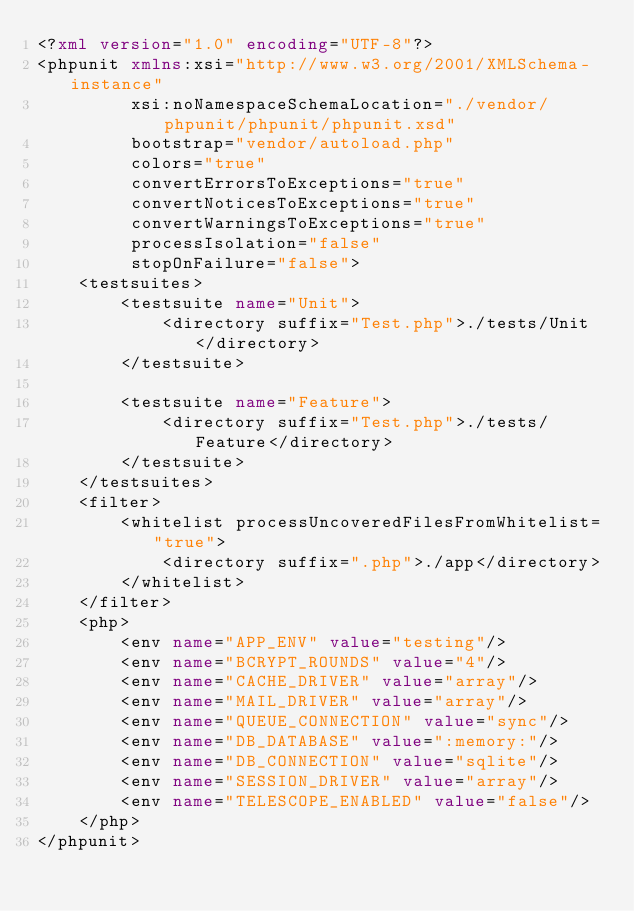Convert code to text. <code><loc_0><loc_0><loc_500><loc_500><_XML_><?xml version="1.0" encoding="UTF-8"?>
<phpunit xmlns:xsi="http://www.w3.org/2001/XMLSchema-instance"
         xsi:noNamespaceSchemaLocation="./vendor/phpunit/phpunit/phpunit.xsd"
         bootstrap="vendor/autoload.php"
         colors="true"
         convertErrorsToExceptions="true"
         convertNoticesToExceptions="true"
         convertWarningsToExceptions="true"
         processIsolation="false"
         stopOnFailure="false">
    <testsuites>
        <testsuite name="Unit">
            <directory suffix="Test.php">./tests/Unit</directory>
        </testsuite>

        <testsuite name="Feature">
            <directory suffix="Test.php">./tests/Feature</directory>
        </testsuite>
    </testsuites>
    <filter>
        <whitelist processUncoveredFilesFromWhitelist="true">
            <directory suffix=".php">./app</directory>
        </whitelist>
    </filter>
    <php>
        <env name="APP_ENV" value="testing"/>
        <env name="BCRYPT_ROUNDS" value="4"/>
        <env name="CACHE_DRIVER" value="array"/>
        <env name="MAIL_DRIVER" value="array"/>
        <env name="QUEUE_CONNECTION" value="sync"/>
        <env name="DB_DATABASE" value=":memory:"/>
        <env name="DB_CONNECTION" value="sqlite"/>
        <env name="SESSION_DRIVER" value="array"/>
        <env name="TELESCOPE_ENABLED" value="false"/>
    </php>
</phpunit>
</code> 